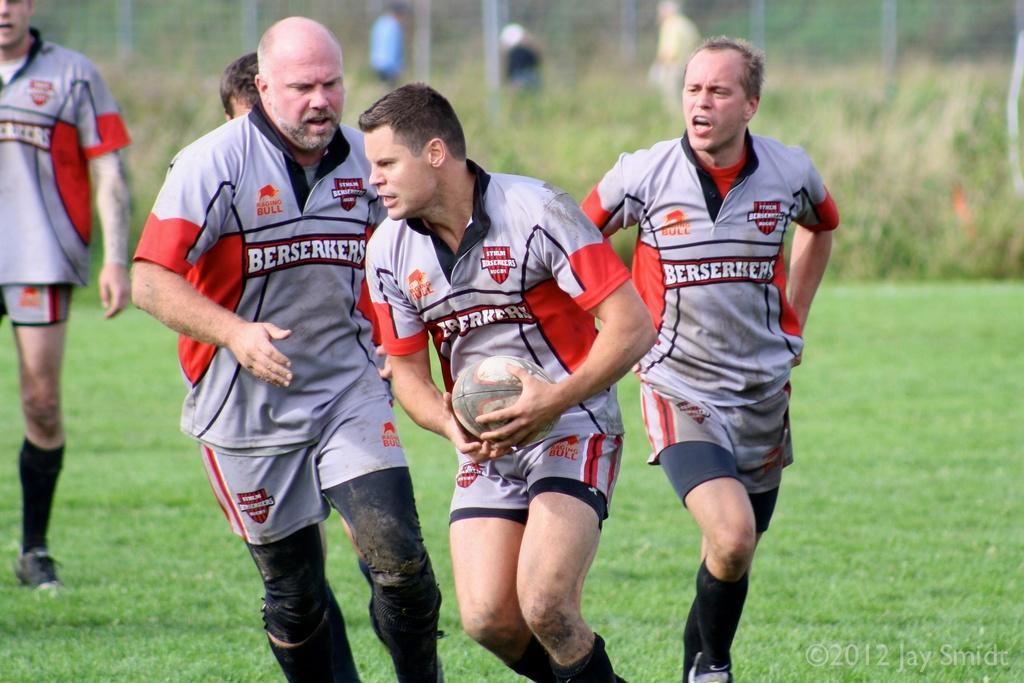In one or two sentences, can you explain what this image depicts? In this image there are group of persons standing, another person standing and holding a ball and the back ground there is grass , and some plants. 